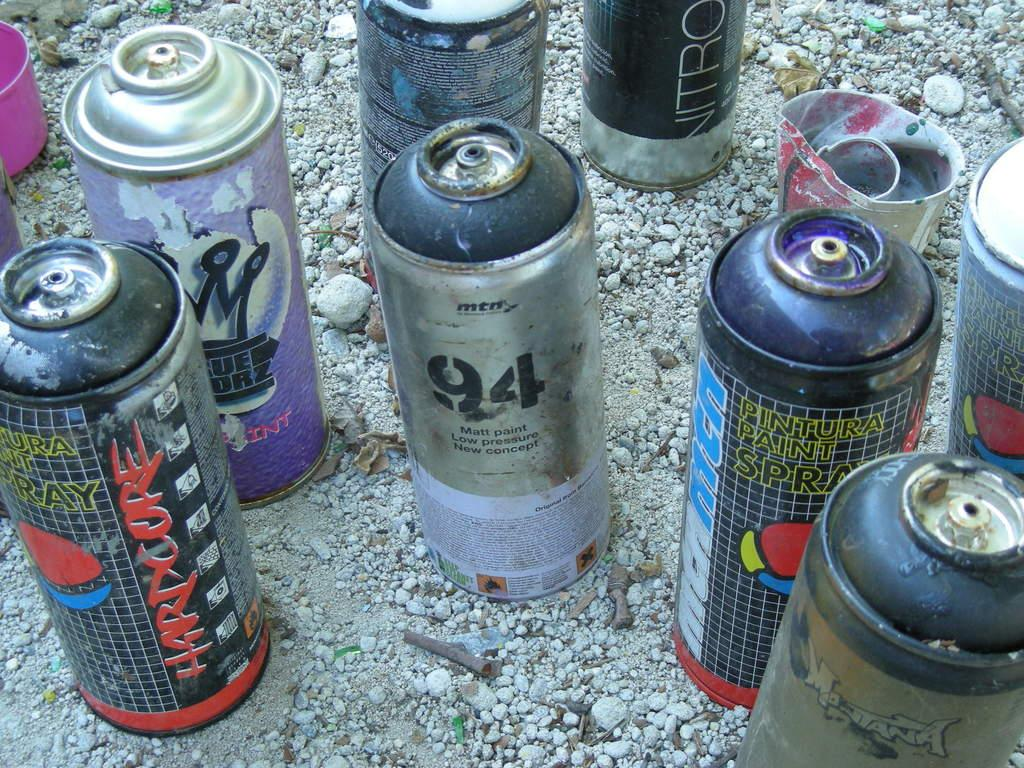<image>
Share a concise interpretation of the image provided. a few cans with one that has the number 94 on it 